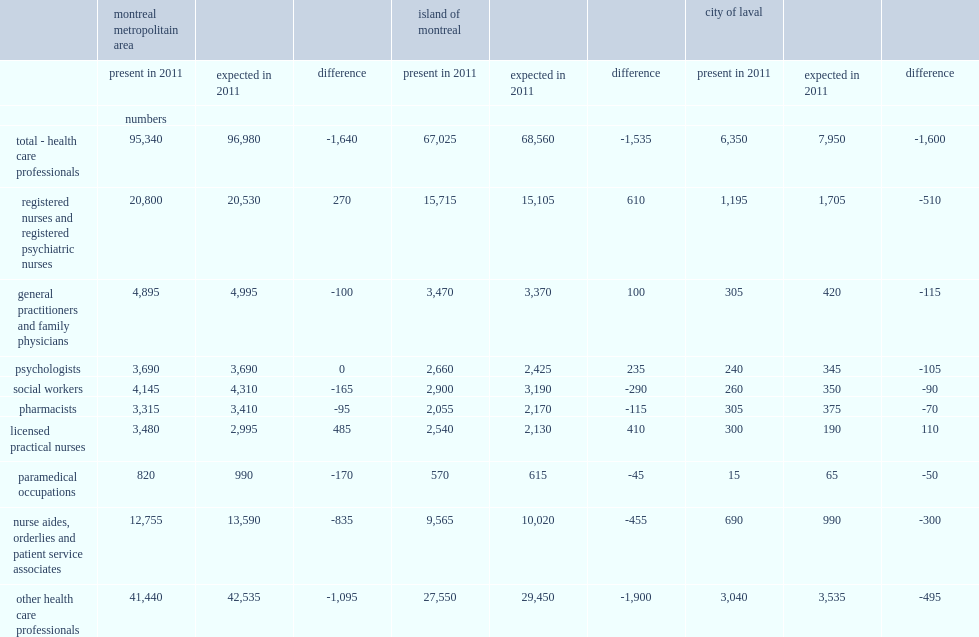What was the number of shortfalls of professionals able to provide health care services in the montreal region in 2011? 1640. 